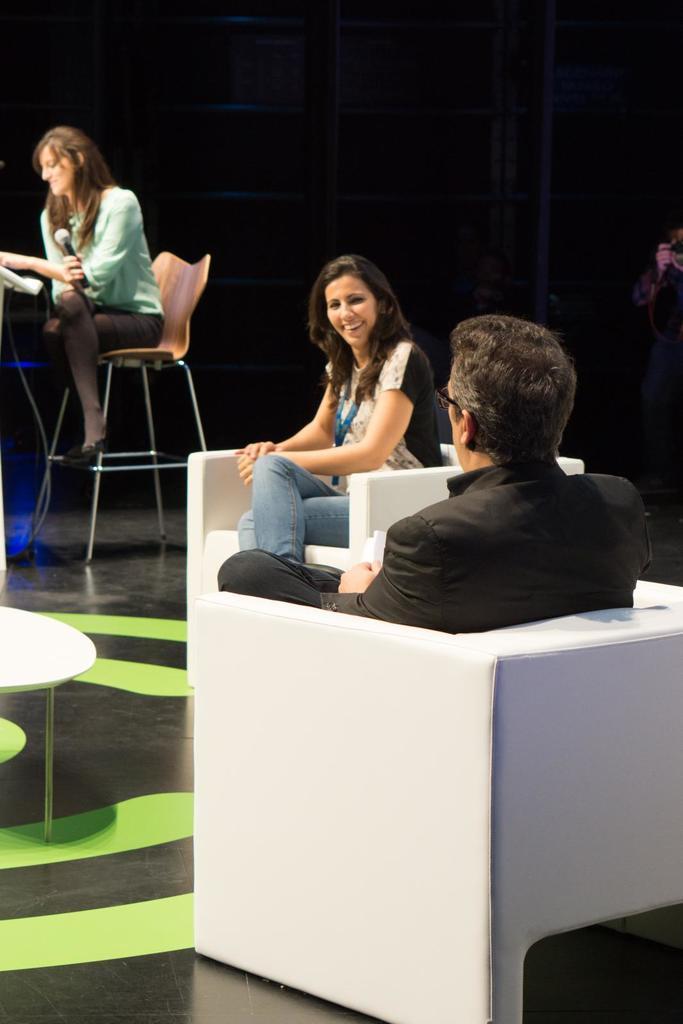Please provide a concise description of this image. In this image, we can see three people are sitting on the chairs. Here a woman is holding a microphone. At the bottom, we can see surface. Left side of the image, there is a table. Right side of the image, we can see a person is standing and holding a camera. Background there is a dark view. Here we can see rods. In the middle of the image, a woman is smiling and watching. 